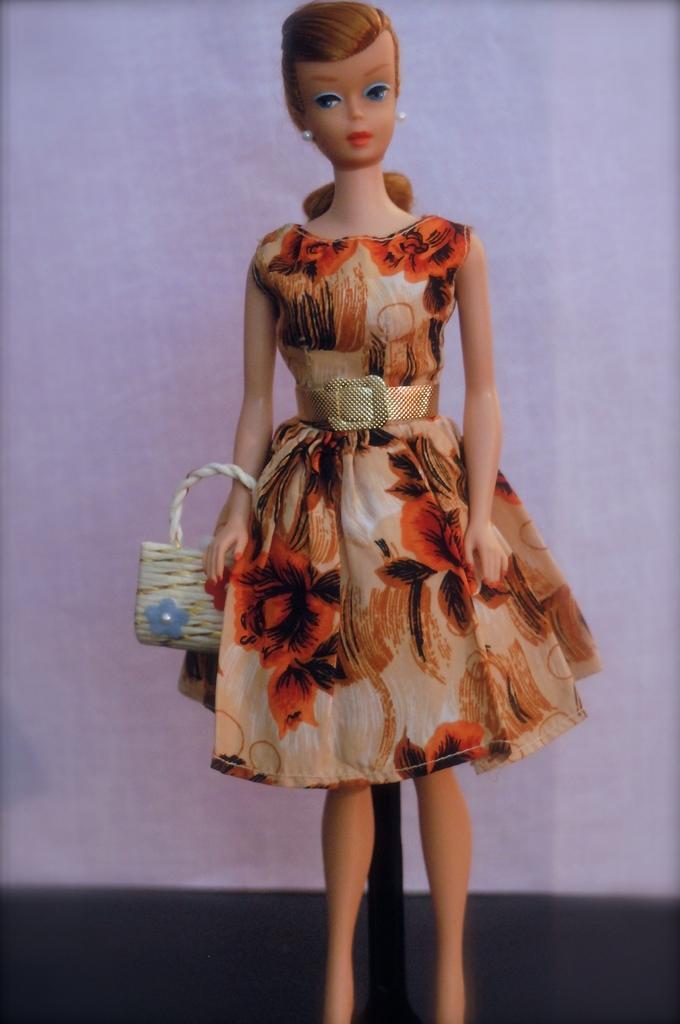Describe this image in one or two sentences. In the picture we can see a Barbie doll standing, holding a handbag and in the background, we can see a wall which is light blue in color. 